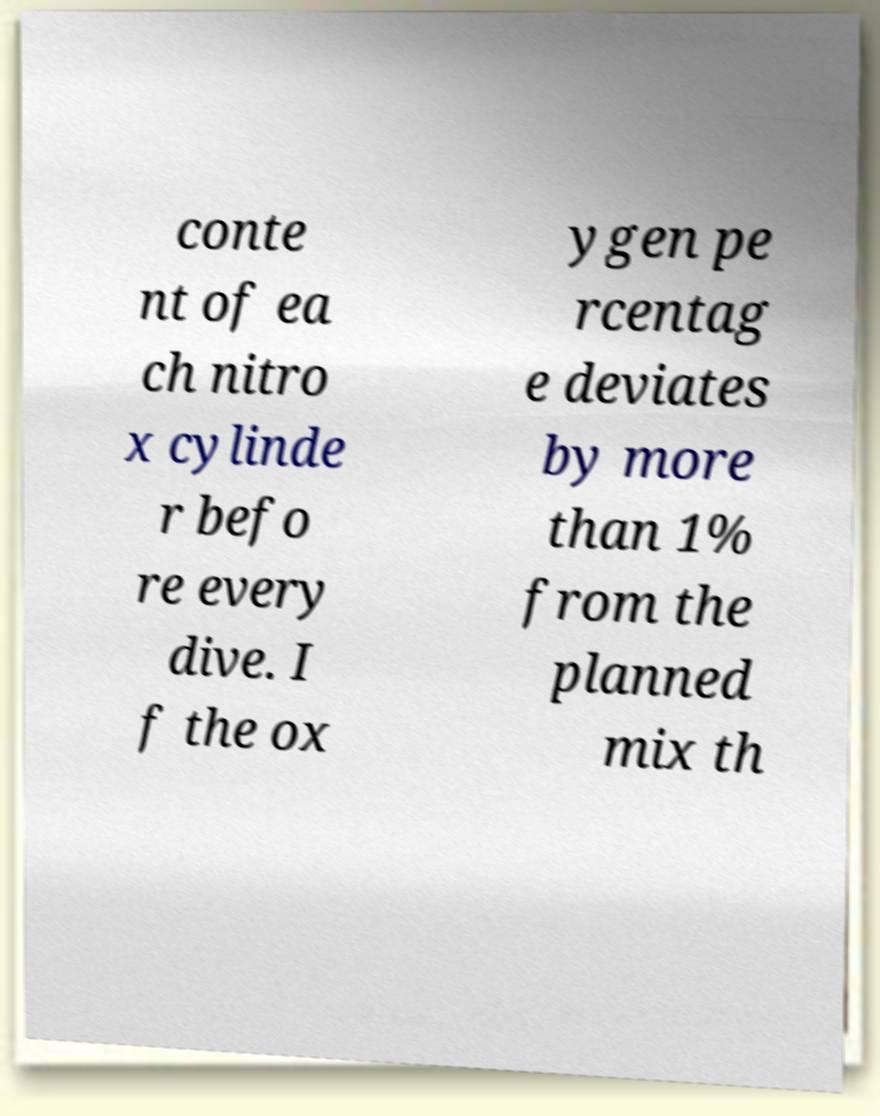What messages or text are displayed in this image? I need them in a readable, typed format. conte nt of ea ch nitro x cylinde r befo re every dive. I f the ox ygen pe rcentag e deviates by more than 1% from the planned mix th 